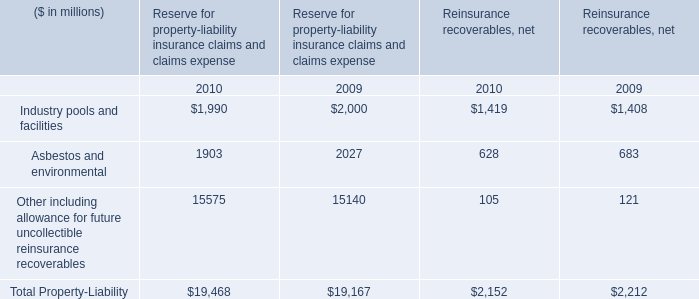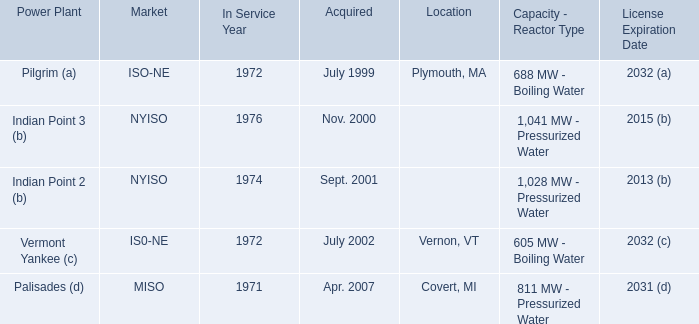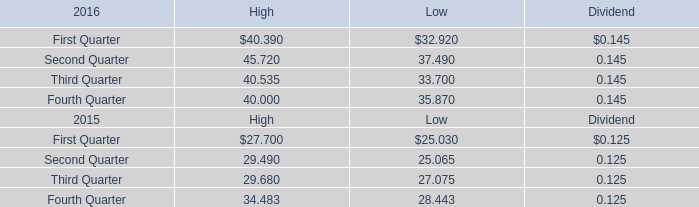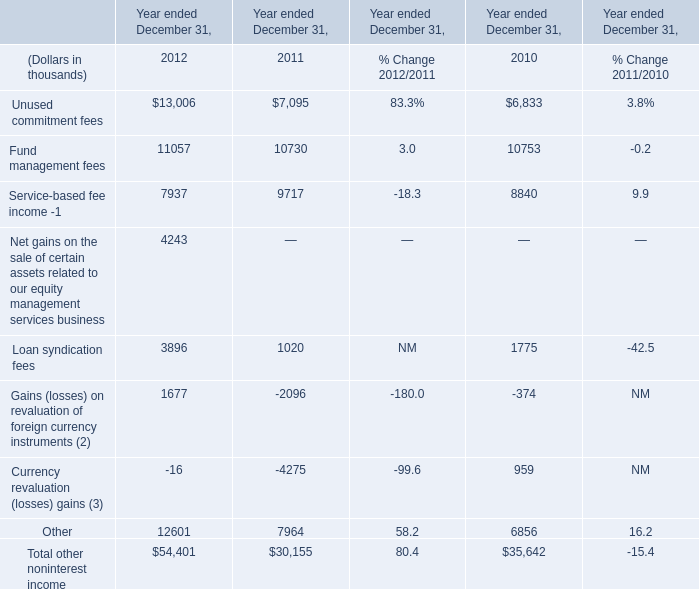What was the sum of 2012 without those 2012 smaller than 10000 in 2012 for Year ended December 31,? (in thousand) 
Computations: ((13006 + 11057) + 12601)
Answer: 36664.0. 